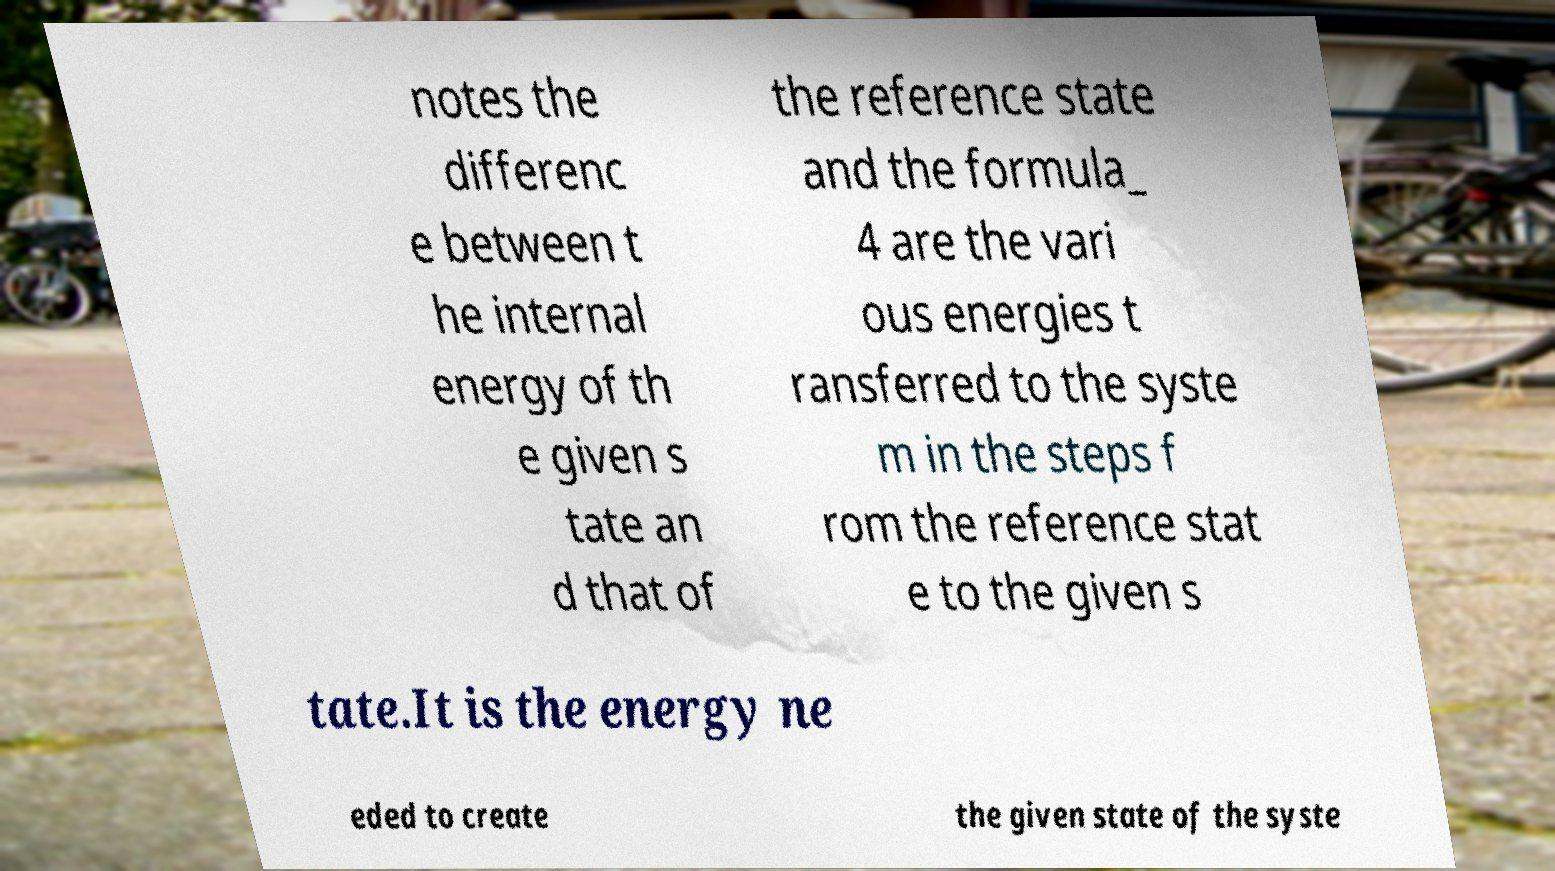What messages or text are displayed in this image? I need them in a readable, typed format. notes the differenc e between t he internal energy of th e given s tate an d that of the reference state and the formula_ 4 are the vari ous energies t ransferred to the syste m in the steps f rom the reference stat e to the given s tate.It is the energy ne eded to create the given state of the syste 